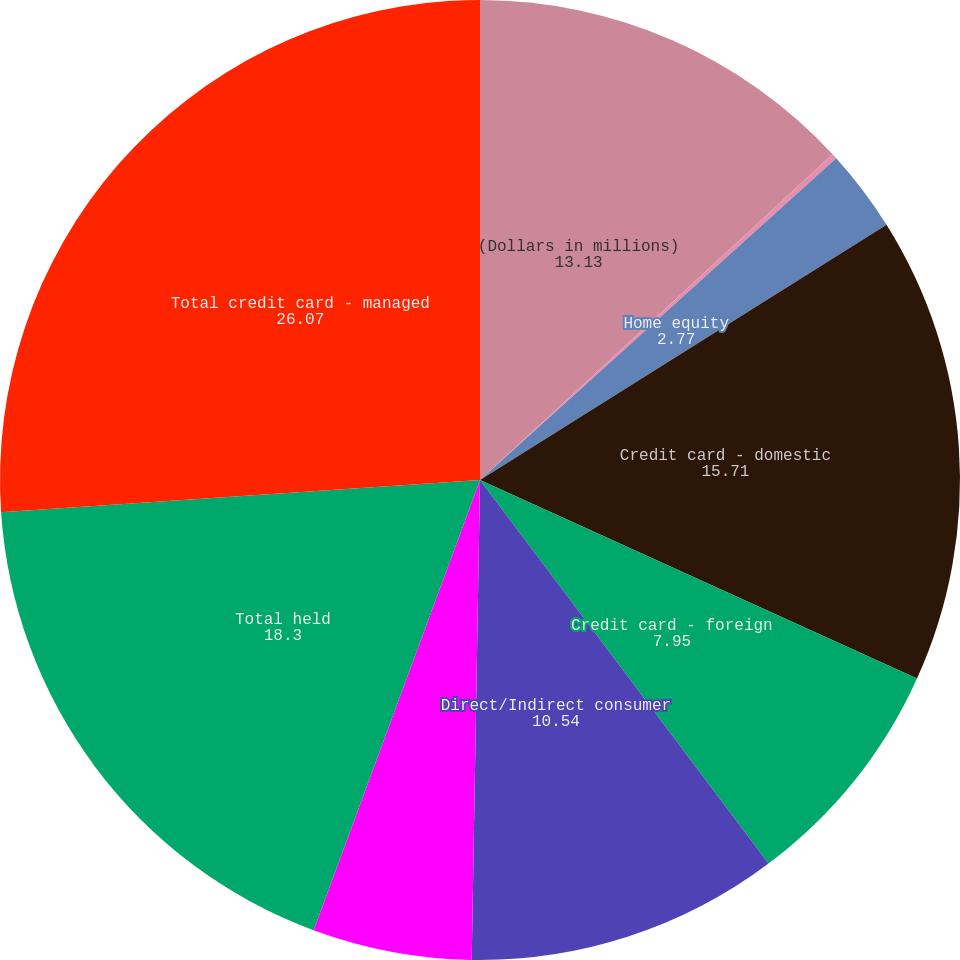Convert chart. <chart><loc_0><loc_0><loc_500><loc_500><pie_chart><fcel>(Dollars in millions)<fcel>Residential mortgage<fcel>Home equity<fcel>Credit card - domestic<fcel>Credit card - foreign<fcel>Direct/Indirect consumer<fcel>Other consumer<fcel>Total held<fcel>Total credit card - managed<nl><fcel>13.13%<fcel>0.18%<fcel>2.77%<fcel>15.71%<fcel>7.95%<fcel>10.54%<fcel>5.36%<fcel>18.3%<fcel>26.07%<nl></chart> 